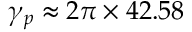<formula> <loc_0><loc_0><loc_500><loc_500>\gamma _ { p } \approx 2 \pi \times 4 2 . 5 8</formula> 